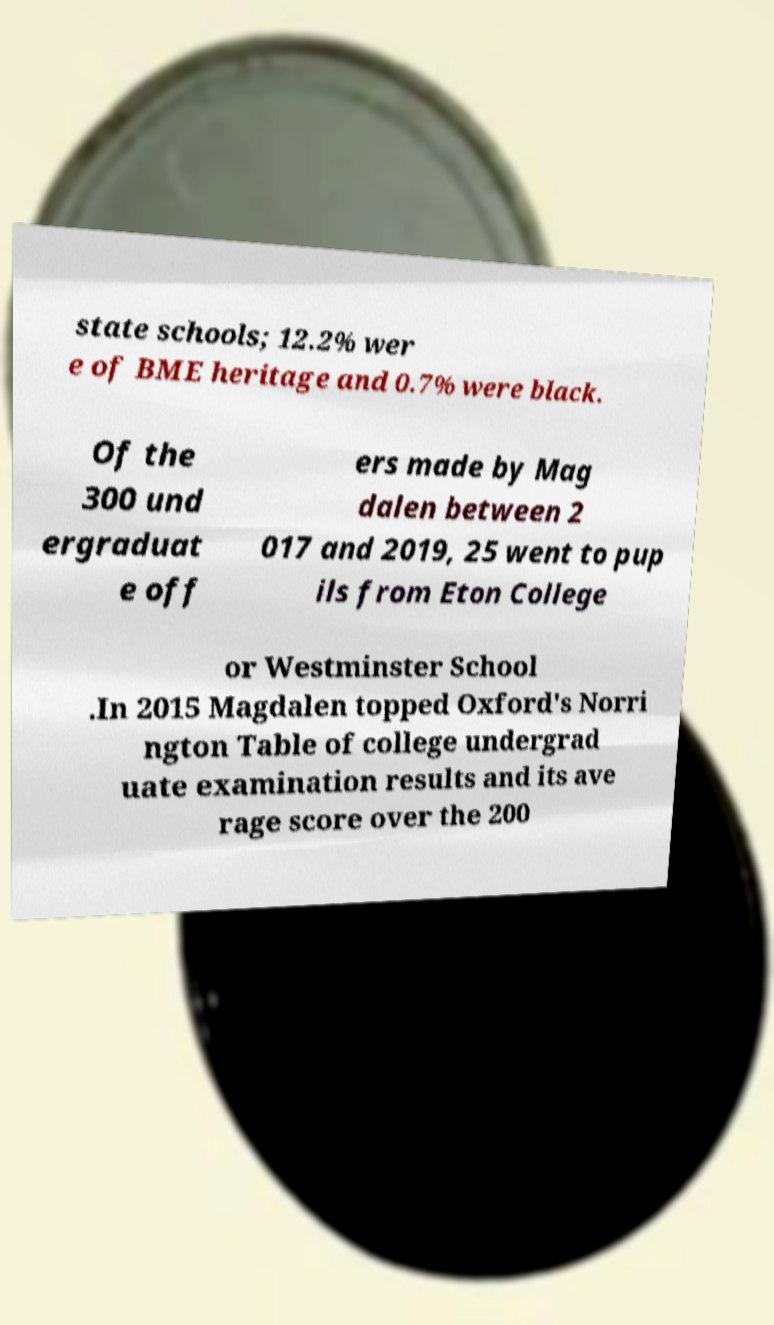For documentation purposes, I need the text within this image transcribed. Could you provide that? state schools; 12.2% wer e of BME heritage and 0.7% were black. Of the 300 und ergraduat e off ers made by Mag dalen between 2 017 and 2019, 25 went to pup ils from Eton College or Westminster School .In 2015 Magdalen topped Oxford's Norri ngton Table of college undergrad uate examination results and its ave rage score over the 200 